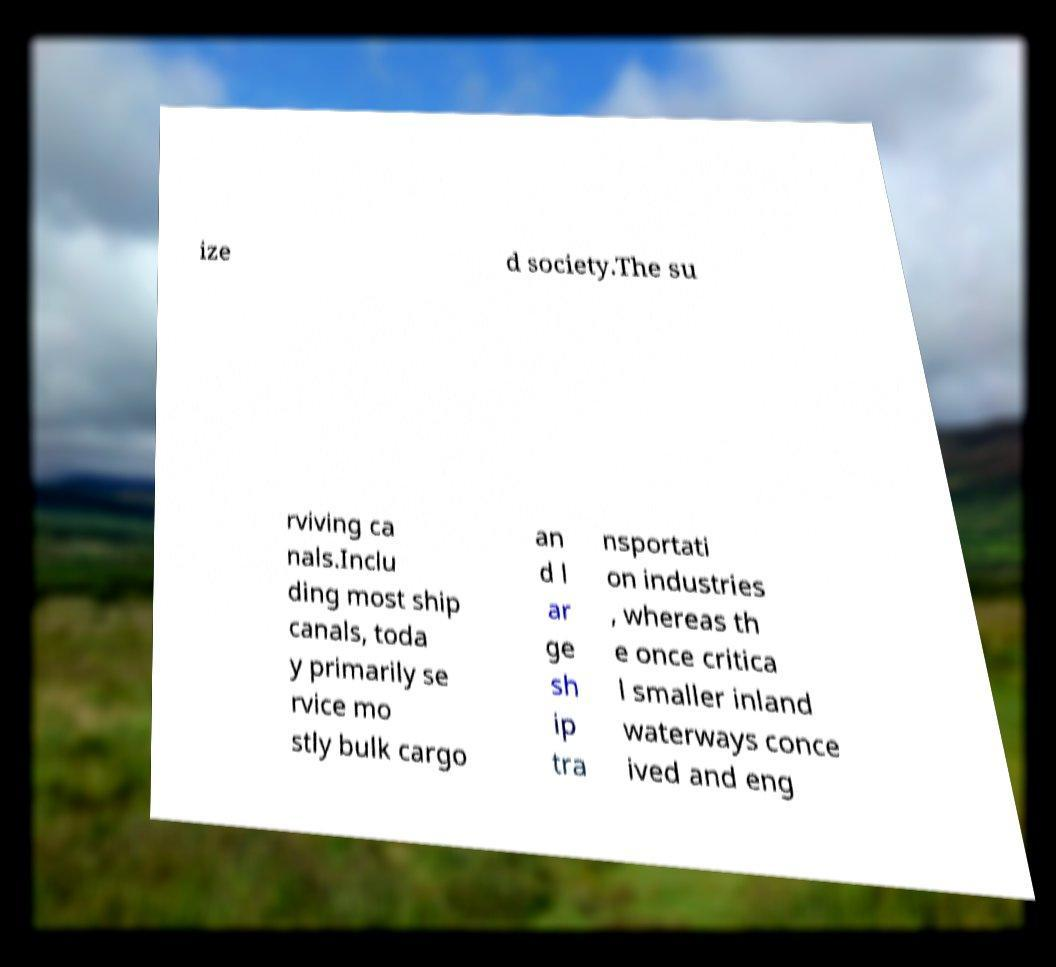What messages or text are displayed in this image? I need them in a readable, typed format. ize d society.The su rviving ca nals.Inclu ding most ship canals, toda y primarily se rvice mo stly bulk cargo an d l ar ge sh ip tra nsportati on industries , whereas th e once critica l smaller inland waterways conce ived and eng 